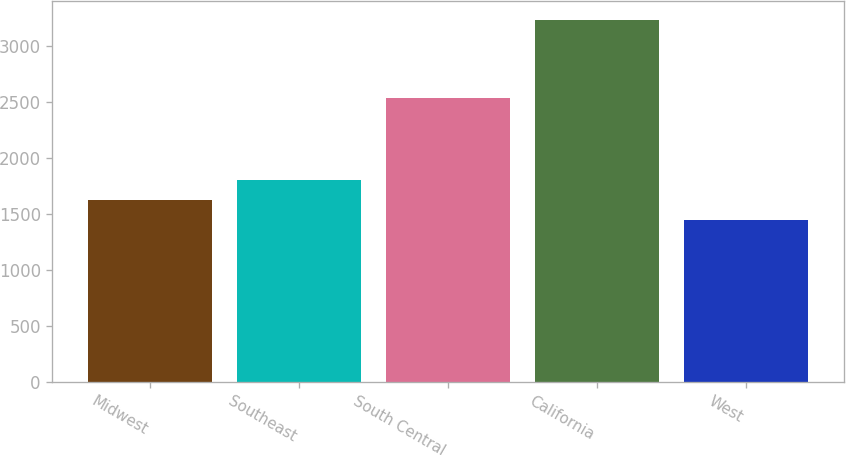Convert chart. <chart><loc_0><loc_0><loc_500><loc_500><bar_chart><fcel>Midwest<fcel>Southeast<fcel>South Central<fcel>California<fcel>West<nl><fcel>1629.58<fcel>1808.36<fcel>2536.4<fcel>3238.6<fcel>1450.8<nl></chart> 